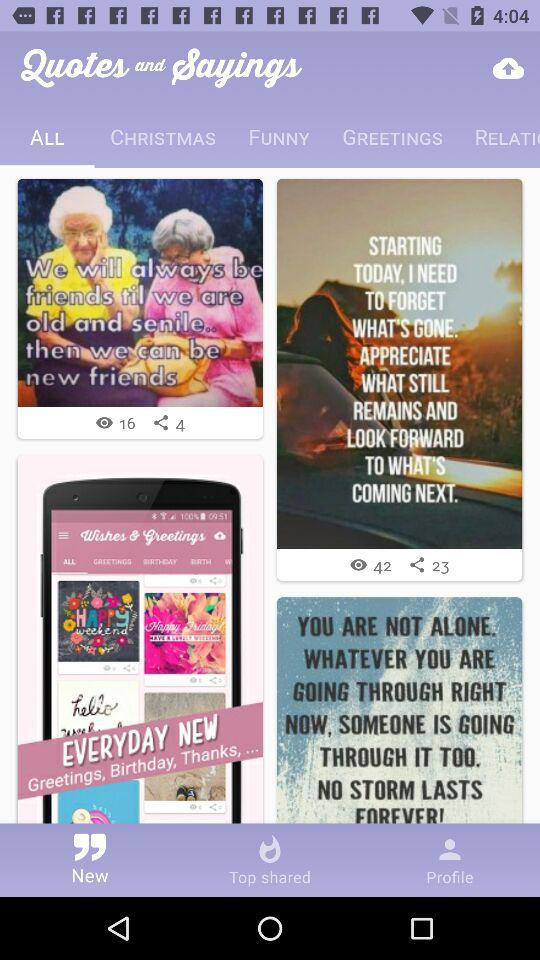How many views are there for "STARTING TODAY, I NEED TO FORGET"? There are 42 views. 